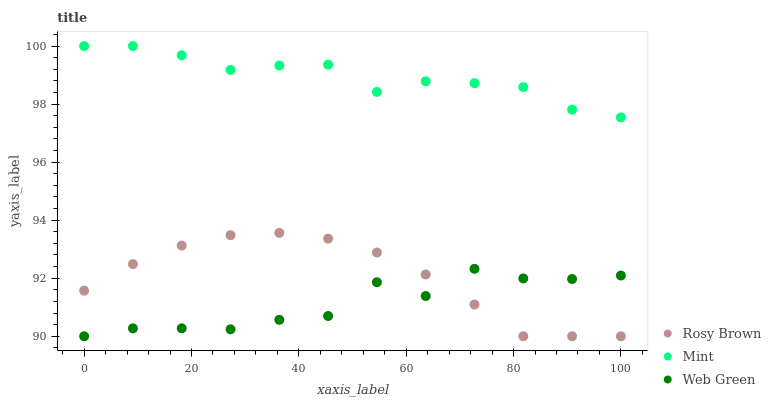Does Web Green have the minimum area under the curve?
Answer yes or no. Yes. Does Mint have the maximum area under the curve?
Answer yes or no. Yes. Does Mint have the minimum area under the curve?
Answer yes or no. No. Does Web Green have the maximum area under the curve?
Answer yes or no. No. Is Rosy Brown the smoothest?
Answer yes or no. Yes. Is Web Green the roughest?
Answer yes or no. Yes. Is Mint the smoothest?
Answer yes or no. No. Is Mint the roughest?
Answer yes or no. No. Does Rosy Brown have the lowest value?
Answer yes or no. Yes. Does Mint have the lowest value?
Answer yes or no. No. Does Mint have the highest value?
Answer yes or no. Yes. Does Web Green have the highest value?
Answer yes or no. No. Is Rosy Brown less than Mint?
Answer yes or no. Yes. Is Mint greater than Web Green?
Answer yes or no. Yes. Does Web Green intersect Rosy Brown?
Answer yes or no. Yes. Is Web Green less than Rosy Brown?
Answer yes or no. No. Is Web Green greater than Rosy Brown?
Answer yes or no. No. Does Rosy Brown intersect Mint?
Answer yes or no. No. 